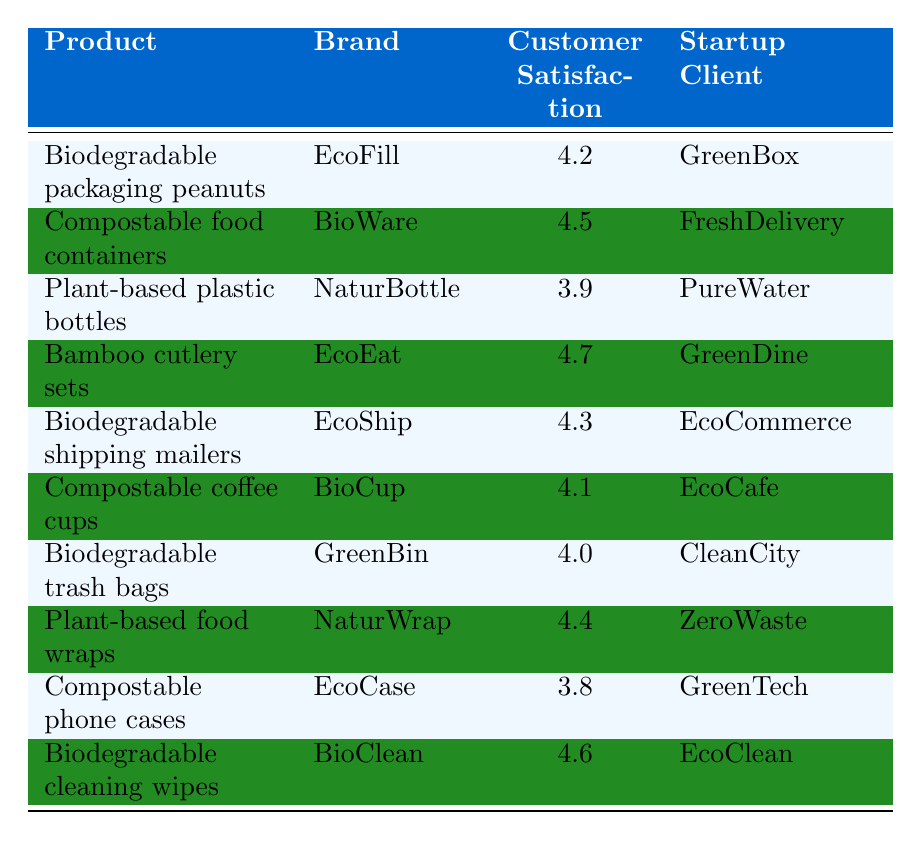What is the customer satisfaction rating for biodegradable packaging peanuts? The table shows that the customer satisfaction rating for biodegradable packaging peanuts by EcoFill is 4.2.
Answer: 4.2 Which product has the highest customer satisfaction rating? The table indicates that bamboo cutlery sets by EcoEat have the highest customer satisfaction rating of 4.7.
Answer: 4.7 How many products have a customer satisfaction rating of 4.0 or higher? The table lists eight products with customer satisfaction ratings of 4.0 or higher: biodegradable packaging peanuts, compostable food containers, bamboo cutlery sets, biodegradable shipping mailers, compostable coffee cups, plant-based food wraps, biodegradable cleaning wipes, and biodegradable trash bags.
Answer: 8 What is the average customer satisfaction rating of all products listed? To find the average, we calculate the sum of all ratings: 4.2 + 4.5 + 3.9 + 4.7 + 4.3 + 4.1 + 4.0 + 4.4 + 3.8 + 4.6 = 44.5, then divide by the number of products (10), resulting in an average of 4.45.
Answer: 4.45 Does the product "Compostable phone cases" have a customer satisfaction rating above 4.0? The table shows that the customer satisfaction rating for compostable phone cases is 3.8, which is not above 4.0.
Answer: No Which brand has the lowest customer satisfaction rating? From the table, NaturBottle has the lowest customer satisfaction rating of 3.9.
Answer: NaturBottle If you combine the ratings of "Biodegradable trash bags" and "Plant-based plastic bottles," what is the sum? The customer satisfaction rating for biodegradable trash bags is 4.0 and for plant-based plastic bottles is 3.9. Adding them together gives: 4.0 + 3.9 = 7.9.
Answer: 7.9 Which startup client is associated with the highest rated product? The highest rated product is bamboo cutlery sets by EcoEat, which is associated with the startup client GreenDine.
Answer: GreenDine How many products listed are associated with GreenBox and EcoClean? GreenBox is associated with biodegradable packaging peanuts, and EcoClean is associated with biodegradable cleaning wipes. Since both clients have only one product each, the total is 2 products.
Answer: 2 Are there more products with a customer satisfaction rating below 4.0 or above? There are three products rated below 4.0 (plant-based plastic bottles, compostable phone cases, biodegradable trash bags) and seven rated above 4.0, meaning more products have a rating above 4.0.
Answer: Above 4.0 